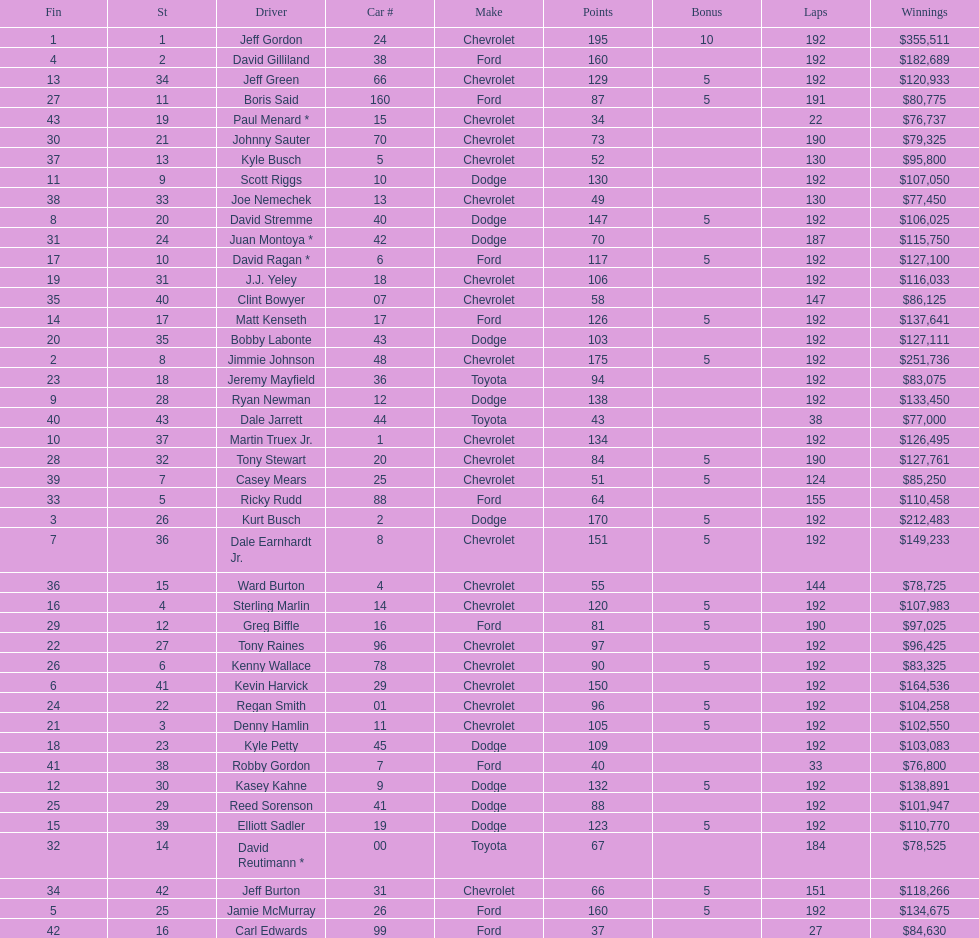What was jimmie johnson's winnings? $251,736. 